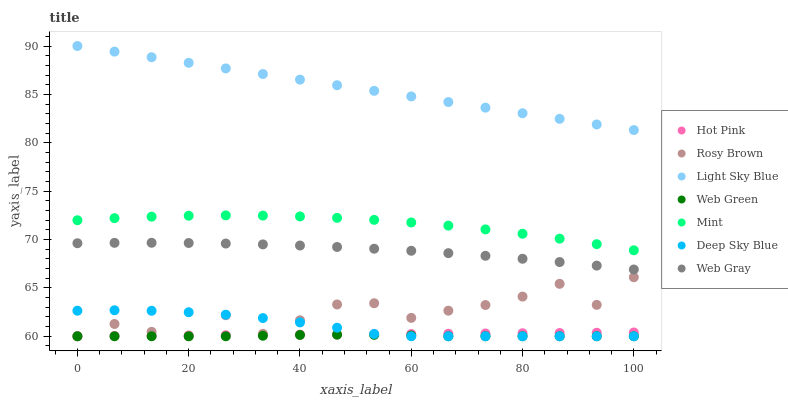Does Web Green have the minimum area under the curve?
Answer yes or no. Yes. Does Light Sky Blue have the maximum area under the curve?
Answer yes or no. Yes. Does Rosy Brown have the minimum area under the curve?
Answer yes or no. No. Does Rosy Brown have the maximum area under the curve?
Answer yes or no. No. Is Light Sky Blue the smoothest?
Answer yes or no. Yes. Is Rosy Brown the roughest?
Answer yes or no. Yes. Is Web Green the smoothest?
Answer yes or no. No. Is Web Green the roughest?
Answer yes or no. No. Does Hot Pink have the lowest value?
Answer yes or no. Yes. Does Light Sky Blue have the lowest value?
Answer yes or no. No. Does Light Sky Blue have the highest value?
Answer yes or no. Yes. Does Rosy Brown have the highest value?
Answer yes or no. No. Is Deep Sky Blue less than Light Sky Blue?
Answer yes or no. Yes. Is Mint greater than Hot Pink?
Answer yes or no. Yes. Does Deep Sky Blue intersect Hot Pink?
Answer yes or no. Yes. Is Deep Sky Blue less than Hot Pink?
Answer yes or no. No. Is Deep Sky Blue greater than Hot Pink?
Answer yes or no. No. Does Deep Sky Blue intersect Light Sky Blue?
Answer yes or no. No. 